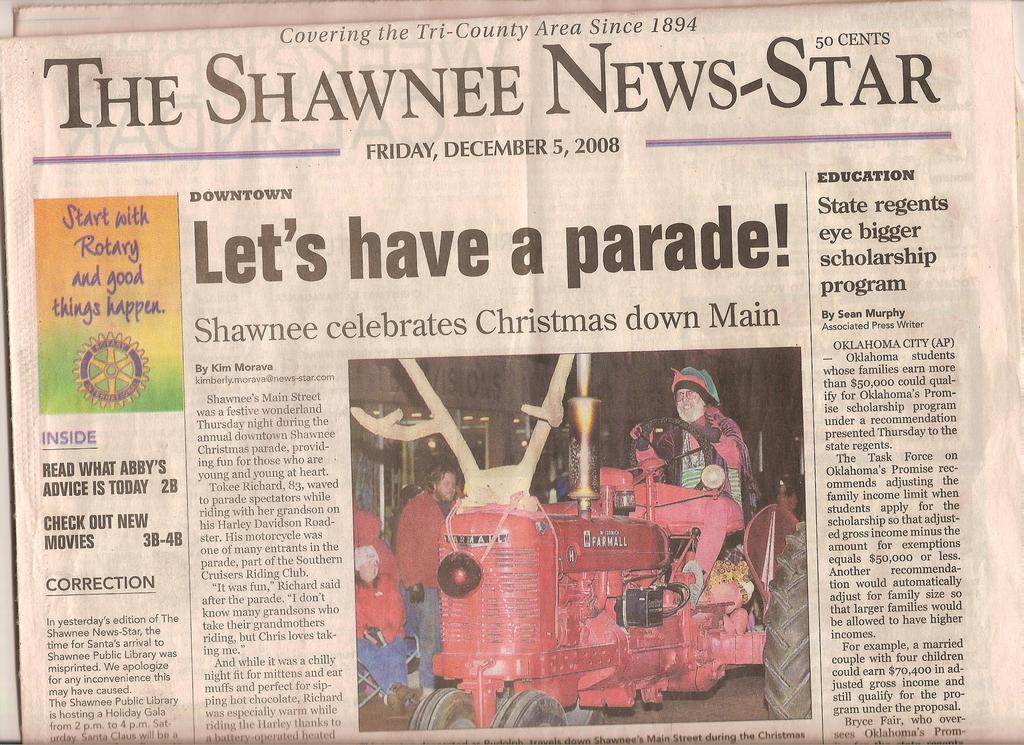<image>
Share a concise interpretation of the image provided. The front-page headline of The Shawnee News-Star is about the parade. 